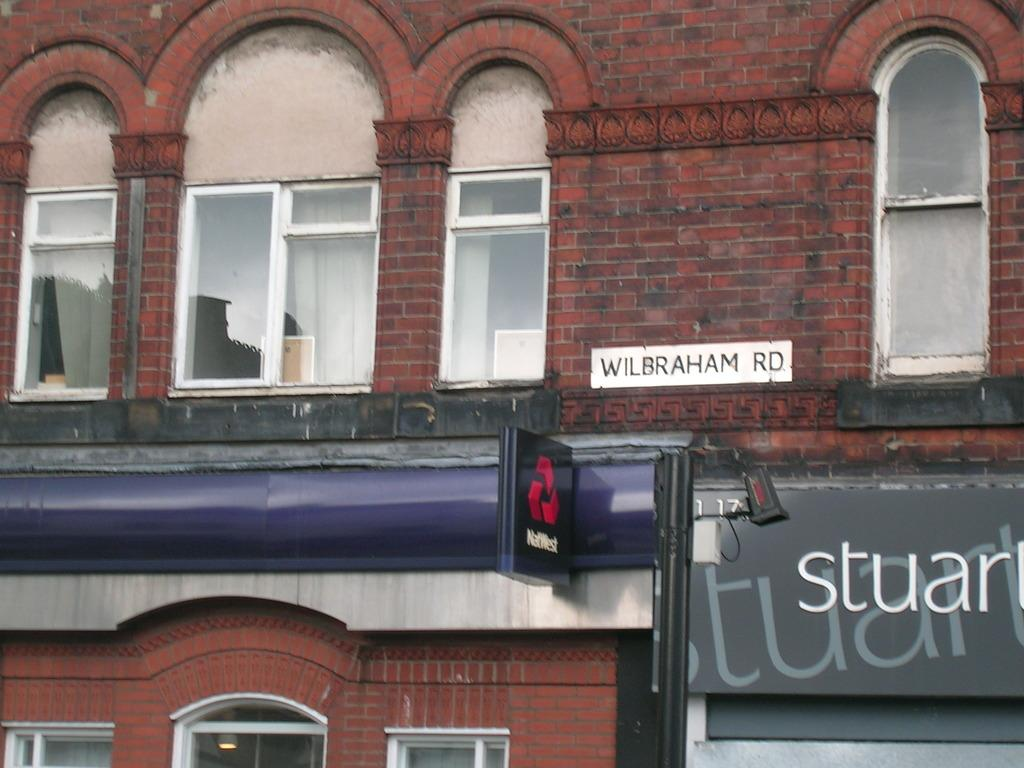What type of structure is visible in the image? There is a building in the image. What feature can be seen on the building? The building has windows. What is located on the right side of the image? There are boards on the right side of the image. What can be found near the boards? There is a light in the image. What is written on the boards? There is writing on the boards. Can you see any faces on the building in the image? There are no faces visible on the building in the image. Are there any planes flying in the sky in the image? The image does not show any planes or the sky, so it is not possible to determine if there are any planes flying. 